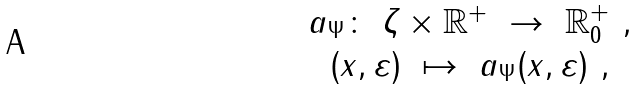Convert formula to latex. <formula><loc_0><loc_0><loc_500><loc_500>\begin{array} { c } a _ { \Psi } \colon \ \zeta \times \mathbb { R } ^ { + } \ \to \ \mathbb { R } _ { 0 } ^ { + } \ , \\ ( x , \varepsilon ) \ \mapsto \ a _ { \Psi } ( x , \varepsilon ) \ , \end{array}</formula> 